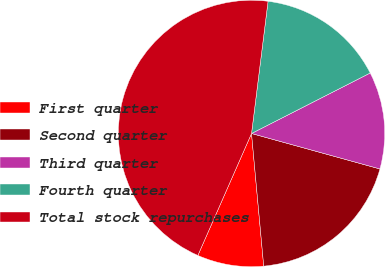Convert chart to OTSL. <chart><loc_0><loc_0><loc_500><loc_500><pie_chart><fcel>First quarter<fcel>Second quarter<fcel>Third quarter<fcel>Fourth quarter<fcel>Total stock repurchases<nl><fcel>8.06%<fcel>19.25%<fcel>11.79%<fcel>15.52%<fcel>45.38%<nl></chart> 